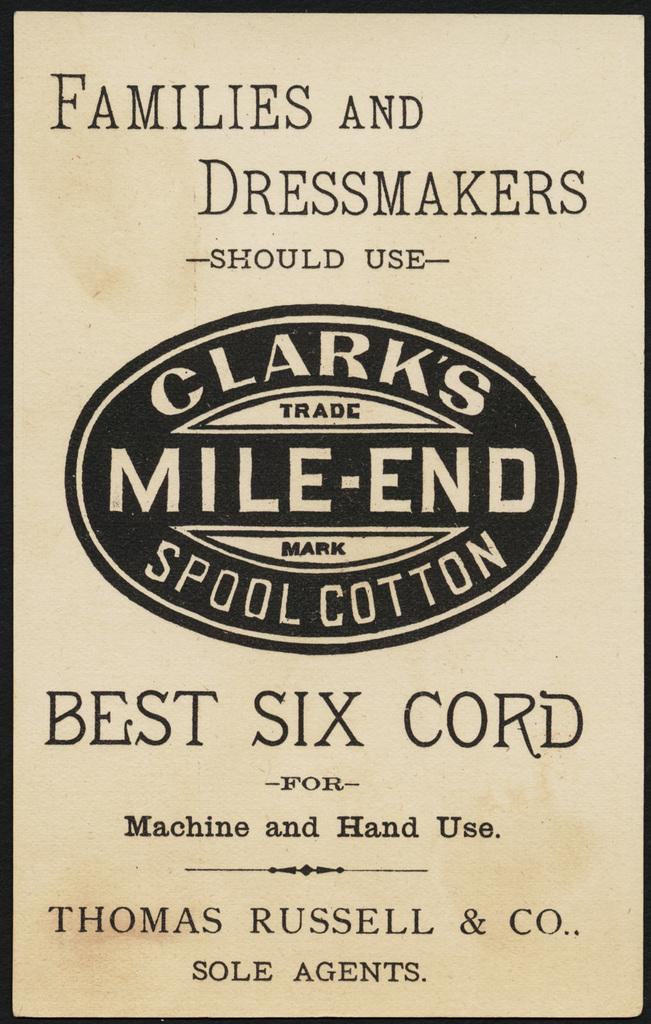<image>
Share a concise interpretation of the image provided. The sign explains that families and dressmakers should use Clark's Mile-End Spool Cotton. 